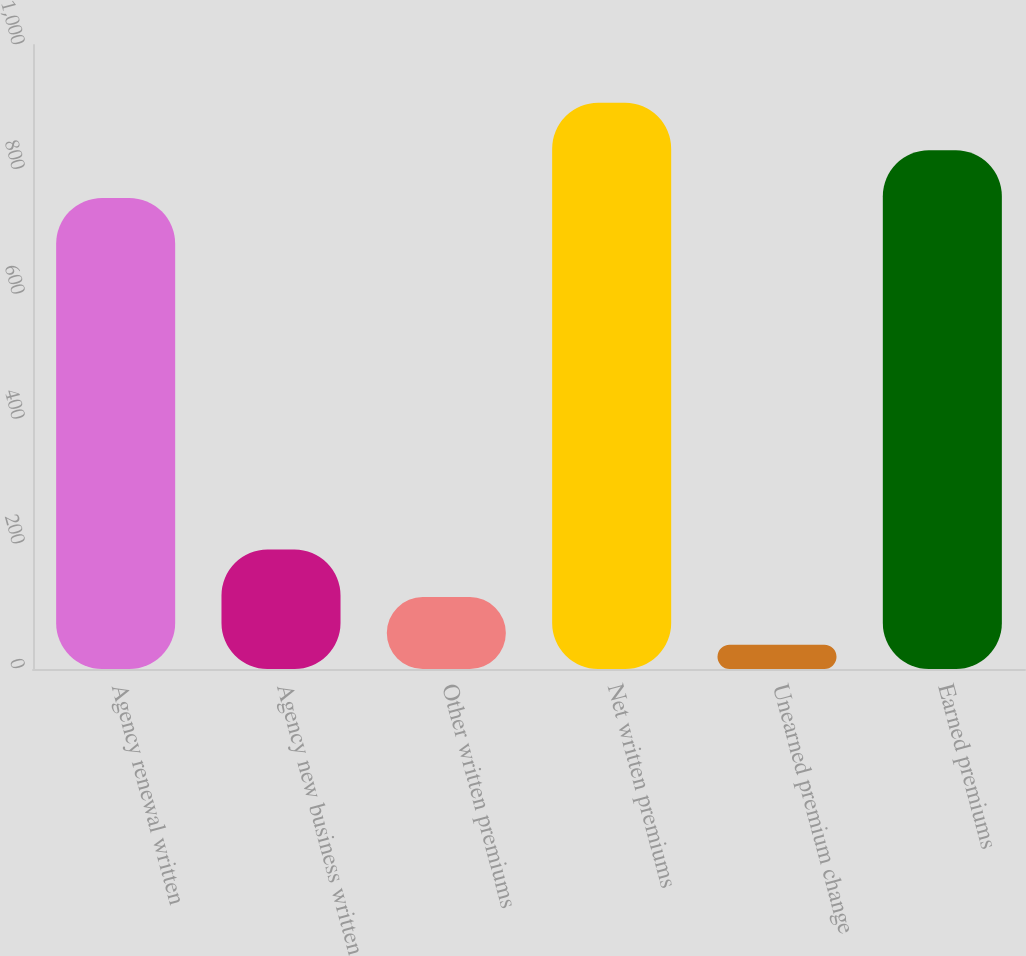Convert chart to OTSL. <chart><loc_0><loc_0><loc_500><loc_500><bar_chart><fcel>Agency renewal written<fcel>Agency new business written<fcel>Other written premiums<fcel>Net written premiums<fcel>Unearned premium change<fcel>Earned premiums<nl><fcel>755<fcel>191.4<fcel>115.2<fcel>907.4<fcel>39<fcel>831.2<nl></chart> 